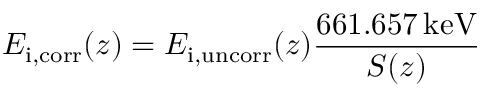<formula> <loc_0><loc_0><loc_500><loc_500>E _ { i , c o r r } ( z ) = E _ { i , u n c o r r } ( z ) \frac { 6 6 1 . 6 5 7 \, k e V } { S ( z ) }</formula> 